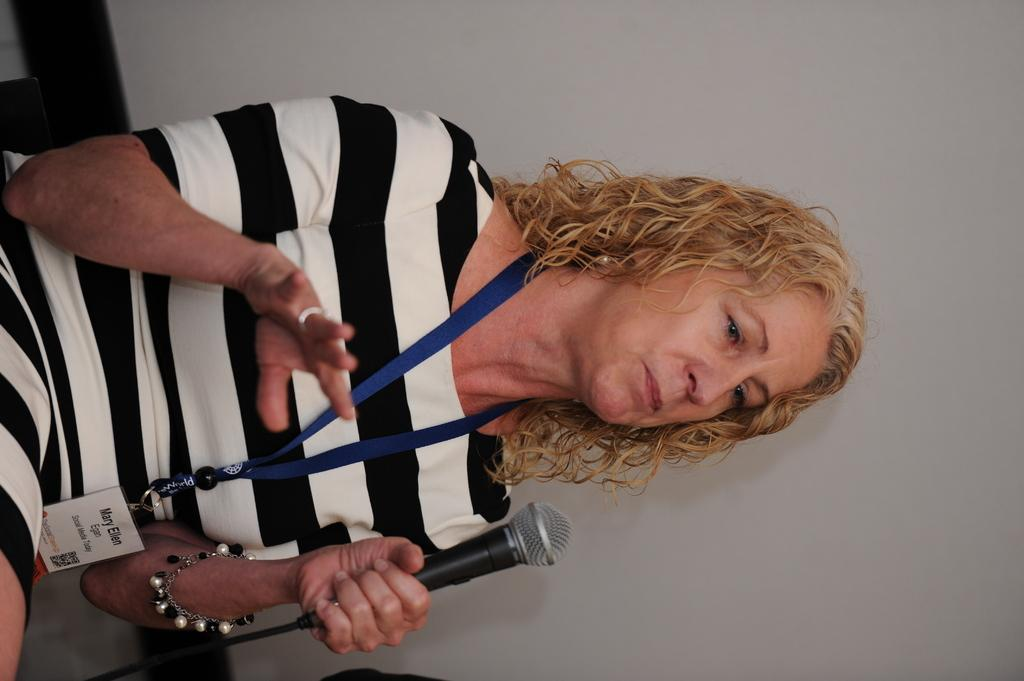Who is the main subject in the image? There is a woman in the image. What is the woman wearing? The woman is wearing a white and black striped dress. What is the woman doing in the image? The woman is sitting and holding a microphone in her hand. What can be seen in the background of the image? There is a wall in the background of the image. How many chances does the woman have to win the lottery in the image? There is no indication of a lottery or chances in the image; it simply shows a woman sitting and holding a microphone. 